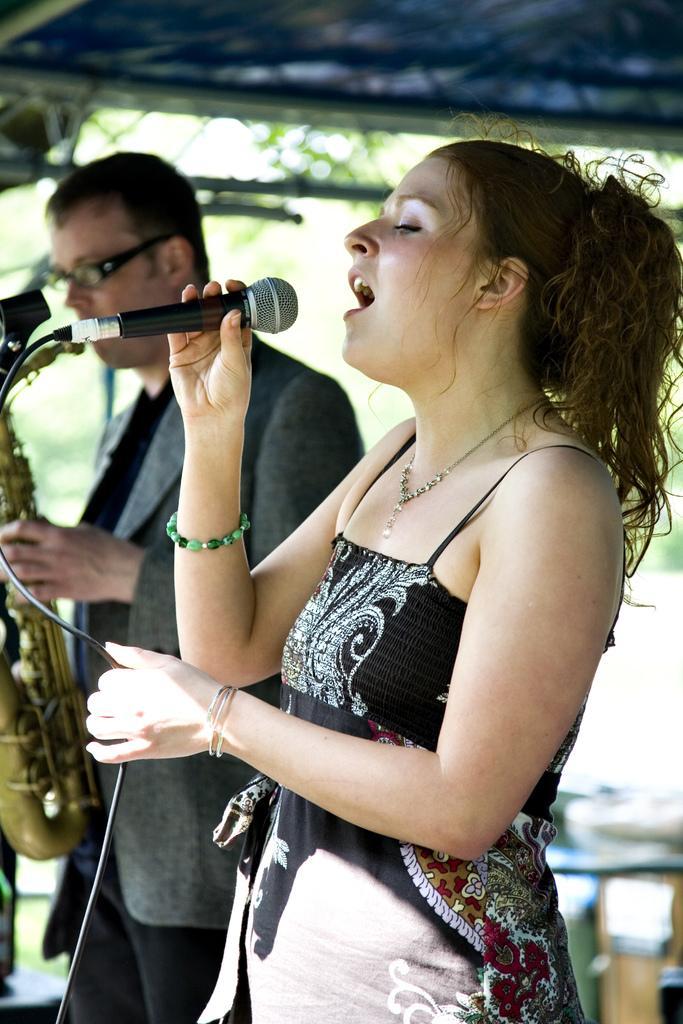Can you describe this image briefly? In this picture a lady is singing a song with a mic in her hands and beside her a guy is playing a saxophone. 